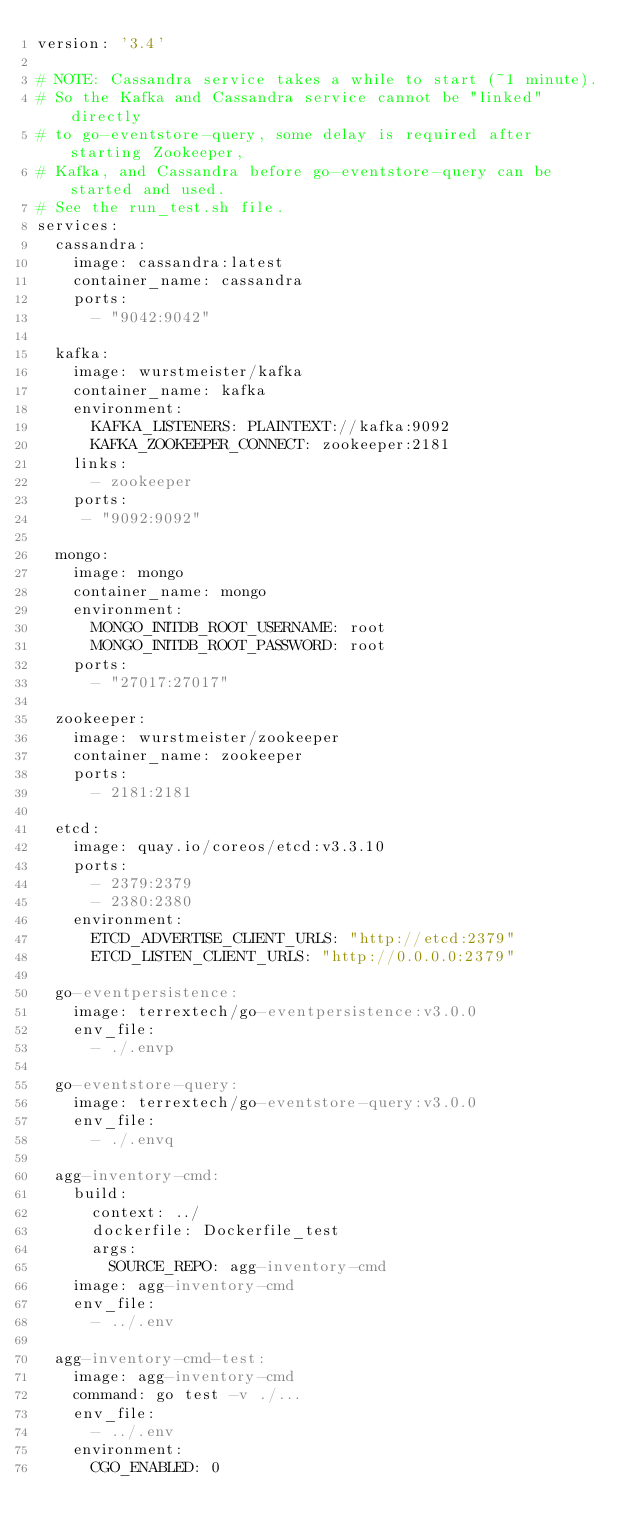Convert code to text. <code><loc_0><loc_0><loc_500><loc_500><_YAML_>version: '3.4'

# NOTE: Cassandra service takes a while to start (~1 minute).
# So the Kafka and Cassandra service cannot be "linked" directly
# to go-eventstore-query, some delay is required after starting Zookeeper,
# Kafka, and Cassandra before go-eventstore-query can be started and used.
# See the run_test.sh file.
services:
  cassandra:
    image: cassandra:latest
    container_name: cassandra
    ports:
      - "9042:9042"

  kafka:
    image: wurstmeister/kafka
    container_name: kafka
    environment:
      KAFKA_LISTENERS: PLAINTEXT://kafka:9092
      KAFKA_ZOOKEEPER_CONNECT: zookeeper:2181
    links:
      - zookeeper
    ports:
     - "9092:9092"

  mongo:
    image: mongo
    container_name: mongo
    environment:
      MONGO_INITDB_ROOT_USERNAME: root
      MONGO_INITDB_ROOT_PASSWORD: root
    ports:
      - "27017:27017"

  zookeeper:
    image: wurstmeister/zookeeper
    container_name: zookeeper
    ports:
      - 2181:2181

  etcd:
    image: quay.io/coreos/etcd:v3.3.10
    ports:
      - 2379:2379
      - 2380:2380
    environment:
      ETCD_ADVERTISE_CLIENT_URLS: "http://etcd:2379"
      ETCD_LISTEN_CLIENT_URLS: "http://0.0.0.0:2379"

  go-eventpersistence:
    image: terrextech/go-eventpersistence:v3.0.0
    env_file:
      - ./.envp

  go-eventstore-query:
    image: terrextech/go-eventstore-query:v3.0.0
    env_file:
      - ./.envq

  agg-inventory-cmd:
    build:
      context: ../
      dockerfile: Dockerfile_test
      args:
        SOURCE_REPO: agg-inventory-cmd
    image: agg-inventory-cmd
    env_file:
      - ../.env

  agg-inventory-cmd-test:
    image: agg-inventory-cmd
    command: go test -v ./...
    env_file:
      - ../.env
    environment:
      CGO_ENABLED: 0
</code> 